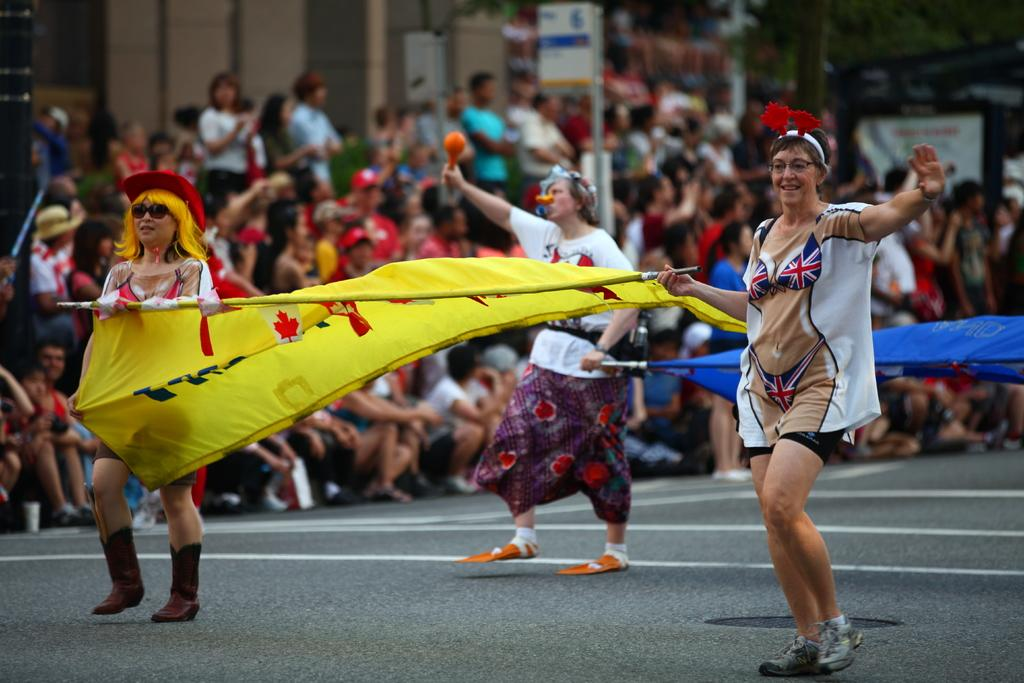What are the people in the image doing on the road? The people in the image are walking on the road. What are the people holding while walking on the road? The people are holding flags. What can be seen in the background of the image? There are many people standing and sitting in front of a building. Can you describe the building visible in the image? The building is visible in the image. What type of beast can be seen roaming around the building in the image? There is no beast present in the image; it features people walking on the road and holding flags, as well as a building in the background. What color is the ink used to write on the flags in the image? There is no indication of the ink color used on the flags in the image, as we cannot see the writing on them. 